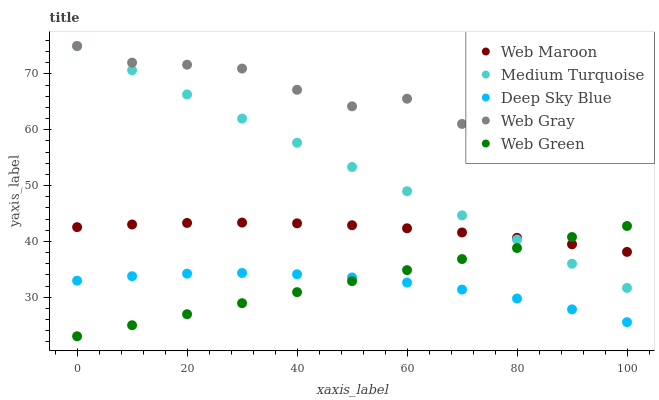Does Deep Sky Blue have the minimum area under the curve?
Answer yes or no. Yes. Does Web Gray have the maximum area under the curve?
Answer yes or no. Yes. Does Web Maroon have the minimum area under the curve?
Answer yes or no. No. Does Web Maroon have the maximum area under the curve?
Answer yes or no. No. Is Web Green the smoothest?
Answer yes or no. Yes. Is Web Gray the roughest?
Answer yes or no. Yes. Is Web Maroon the smoothest?
Answer yes or no. No. Is Web Maroon the roughest?
Answer yes or no. No. Does Web Green have the lowest value?
Answer yes or no. Yes. Does Web Maroon have the lowest value?
Answer yes or no. No. Does Medium Turquoise have the highest value?
Answer yes or no. Yes. Does Web Maroon have the highest value?
Answer yes or no. No. Is Deep Sky Blue less than Web Gray?
Answer yes or no. Yes. Is Web Gray greater than Web Maroon?
Answer yes or no. Yes. Does Medium Turquoise intersect Web Maroon?
Answer yes or no. Yes. Is Medium Turquoise less than Web Maroon?
Answer yes or no. No. Is Medium Turquoise greater than Web Maroon?
Answer yes or no. No. Does Deep Sky Blue intersect Web Gray?
Answer yes or no. No. 